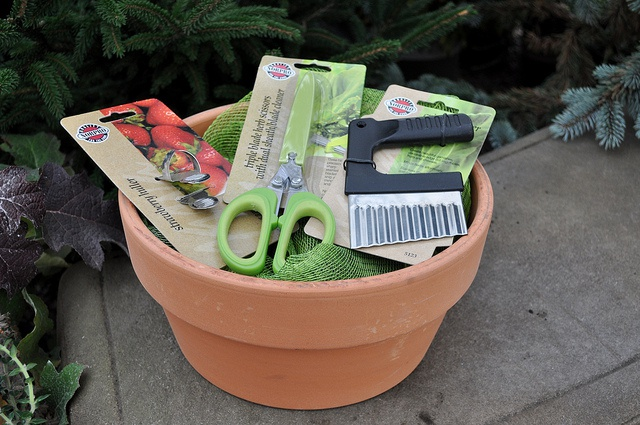Describe the objects in this image and their specific colors. I can see vase in black, salmon, tan, and brown tones and scissors in black, lightgreen, darkgray, and olive tones in this image. 